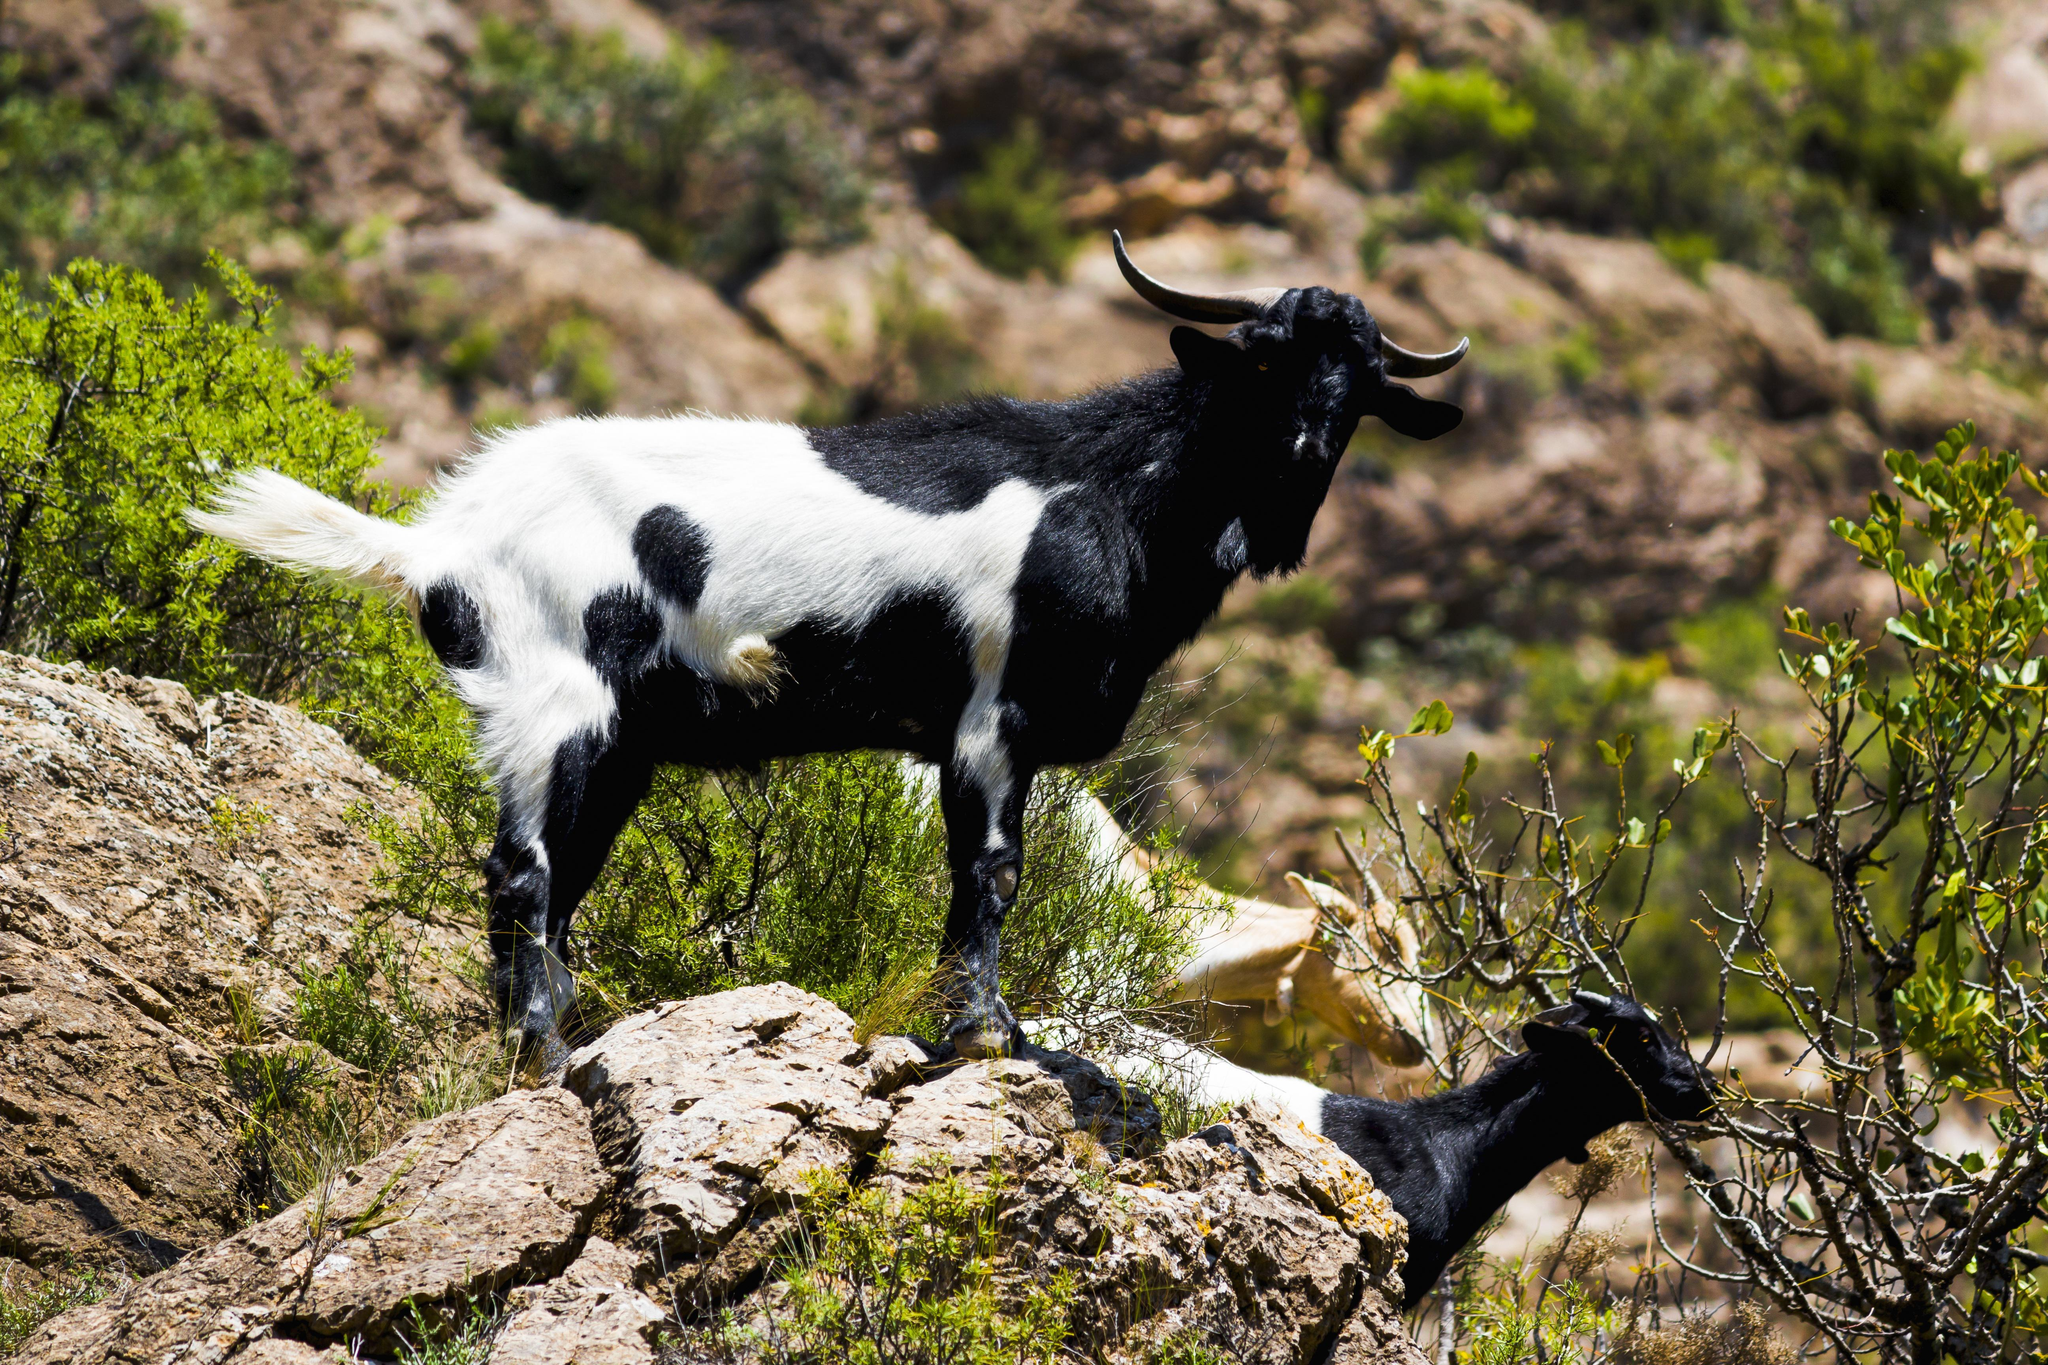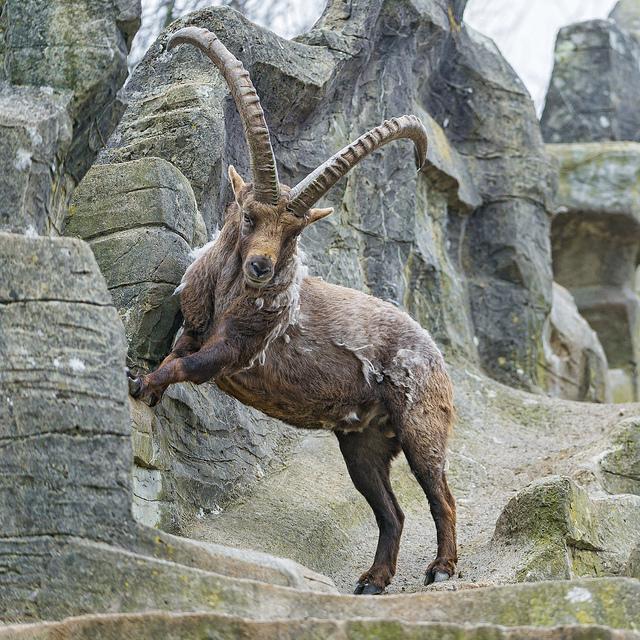The first image is the image on the left, the second image is the image on the right. For the images displayed, is the sentence "exactly one goat is in the image to the right, eating grass." factually correct? Answer yes or no. No. The first image is the image on the left, the second image is the image on the right. For the images shown, is this caption "An image contains at least two hooved animals in an area with green foliage, with at least one animal upright on all fours." true? Answer yes or no. Yes. 